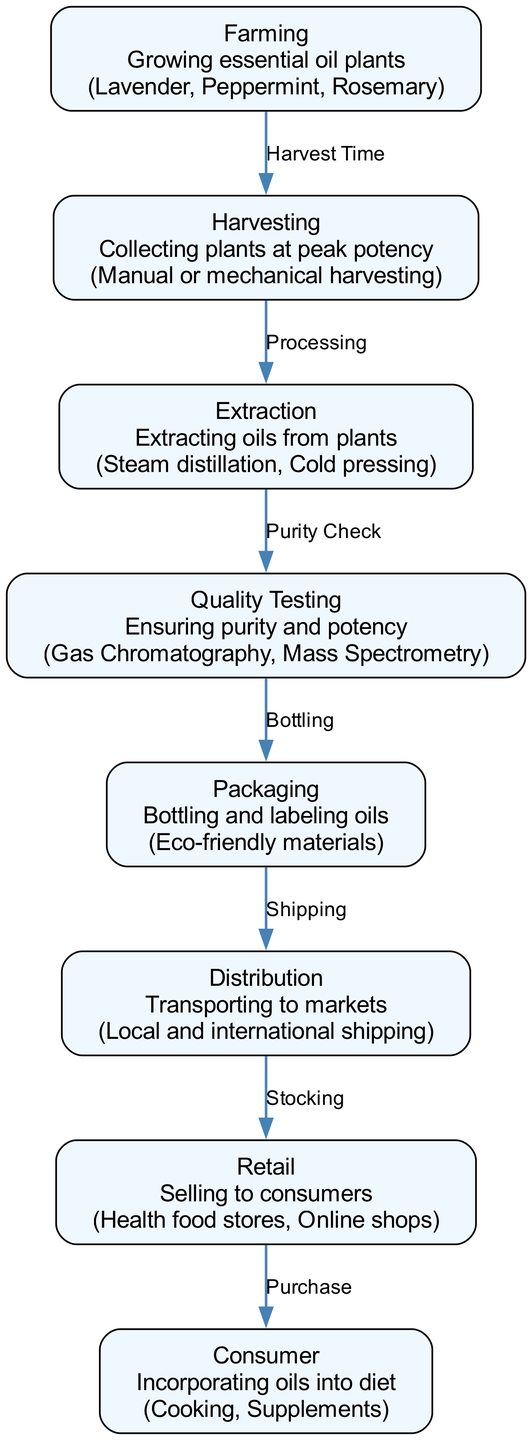What is the first step in the journey of essential oils? The diagram shows that the first step is "Farming", which involves growing essential oil plants. This information is explicitly stated in the node labeled "Farming".
Answer: Farming How many total nodes are present in the diagram? By counting the nodes listed in the diagram, we see there are a total of 8 nodes representing different stages in the journey of essential oils.
Answer: 8 What is the edge label between "Harvesting" and "Extraction"? The diagram specifies the process labeled "Processing" as the edge connecting "Harvesting" to "Extraction". This indicates the transition from collecting the plants to extracting oils.
Answer: Processing Which node ensures the purity and potency of essential oils? According to the diagram, the "Quality Testing" node is responsible for ensuring the purity and potency of essential oils. This is conveyed clearly in the related description.
Answer: Quality Testing What type of materials are used for packaging the oils? The diagram indicates that "Eco-friendly materials" are used for packaging essential oils, as detailed under the "Packaging" node.
Answer: Eco-friendly materials How does oils move from the "Quality Testing" node to the "Packaging" node? The transition from "Quality Testing" to "Packaging" is labeled as "Bottling" in the diagram, indicating that once the oils pass the purity check, they are bottled for packaging.
Answer: Bottling What is the final step in the journey of essential oils before reaching the consumer? The diagram illustrates that the final step before reaching consumers is "Retail", where essential oils are sold to consumers in various outlets.
Answer: Retail Which nodes are involved before essential oils are incorporated into the diet by consumers? The nodes involved before consumer incorporation are "Farming", "Harvesting", "Extraction", "Quality Testing", "Packaging", "Distribution", and "Retail". This shows the entire journey from production to sale before consumer use.
Answer: Farming, Harvesting, Extraction, Quality Testing, Packaging, Distribution, Retail 